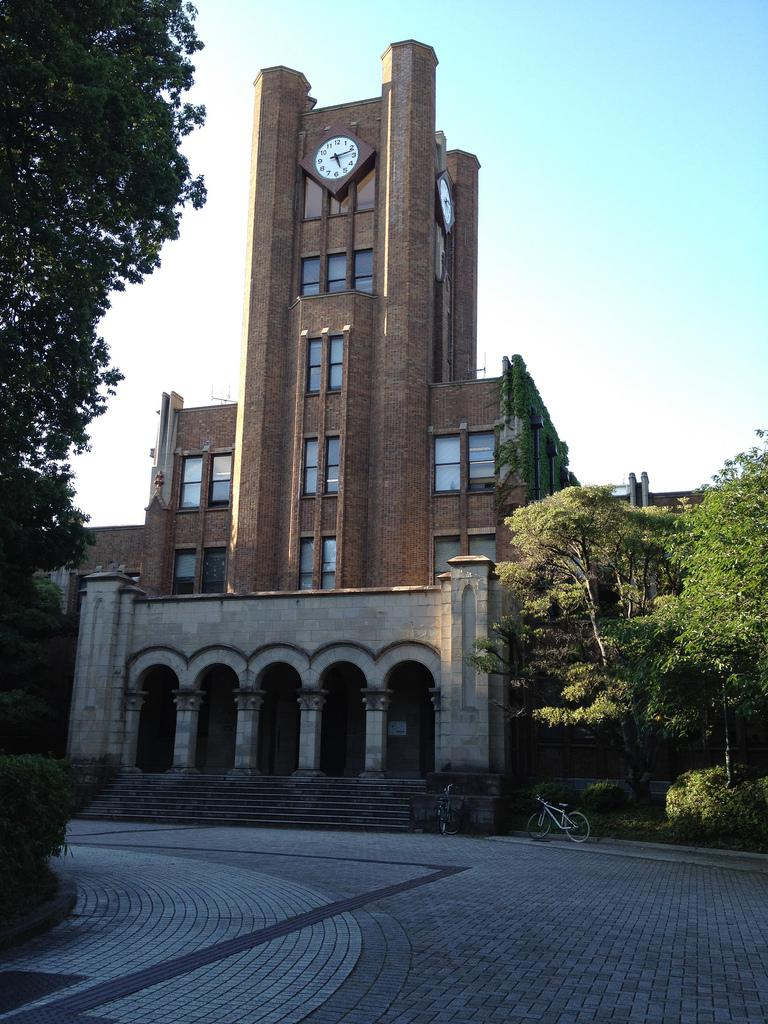Question: where was this picture taken?
Choices:
A. Outside.
B. University campus.
C. At a church.
D. At home.
Answer with the letter. Answer: B Question: what time is on the clock?
Choices:
A. 6:15.
B. 7:19.
C. 3:14.
D. 5:12.
Answer with the letter. Answer: D Question: when will the students get out?
Choices:
A. When the bell rings.
B. When the doors open.
C. When the lecture is over.
D. At end of class.
Answer with the letter. Answer: D Question: how did those bicycles get there?
Choices:
A. Being sold.
B. Crashed.
C. They were built there.
D. Ridden and parked.
Answer with the letter. Answer: D Question: what time of year is this?
Choices:
A. Early autumn.
B. Late summer.
C. Winter.
D. Spring.
Answer with the letter. Answer: B Question: how big is the entrance of the building?
Choices:
A. Huge.
B. Narrow.
C. Small.
D. Wide.
Answer with the letter. Answer: A Question: how many bicycles are parked?
Choices:
A. One.
B. Four.
C. Two.
D. Five.
Answer with the letter. Answer: C Question: what are beside the building?
Choices:
A. Flowers.
B. Trees.
C. Bushes.
D. Cars.
Answer with the letter. Answer: B Question: where are the stairs?
Choices:
A. In the hallway.
B. At the entryway.
C. Building lobby.
D. The front porch.
Answer with the letter. Answer: B Question: what is on the trees?
Choices:
A. Green leaves.
B. Moss.
C. Limbs.
D. Bark.
Answer with the letter. Answer: A Question: what is the building made of?
Choices:
A. Wood.
B. Adobe.
C. Concrete.
D. Bricks.
Answer with the letter. Answer: D Question: where are the arches?
Choices:
A. Garden entrance.
B. The ballroom.
C. At the building's entry.
D. Stadium.
Answer with the letter. Answer: C Question: how does the sky look?
Choices:
A. Blue.
B. Sunny.
C. Clear.
D. Hazy.
Answer with the letter. Answer: C Question: what is in a circular motion?
Choices:
A. The brick.
B. Tire.
C. Stone.
D. Ball.
Answer with the letter. Answer: A Question: what leads up to the building?
Choices:
A. Sidewalk.
B. Steps.
C. Bricks.
D. Pavement.
Answer with the letter. Answer: B Question: what time is it?
Choices:
A. It's 4:55pm.
B. It is 5:10 in the afternoon.
C. It's 3:22pm.
D. It's 5:55pm.
Answer with the letter. Answer: B Question: what is growing up the wall?
Choices:
A. Morning glories.
B. Moss.
C. Ivy is growing.
D. Thorn bushes.
Answer with the letter. Answer: C Question: what is painted across the pavement?
Choices:
A. A cross walk.
B. The word "stop".
C. Zigzag lines.
D. A warning to use caution.
Answer with the letter. Answer: C Question: what are the center windows shaped like?
Choices:
A. They are tall and narrow.
B. They are wide and square.
C. They are small and round.
D. The are octagonal.
Answer with the letter. Answer: A Question: why is no one present?
Choices:
A. The building is closed.
B. It's late at night.
C. The place isn't ready yet.
D. Classes are in session.
Answer with the letter. Answer: D 